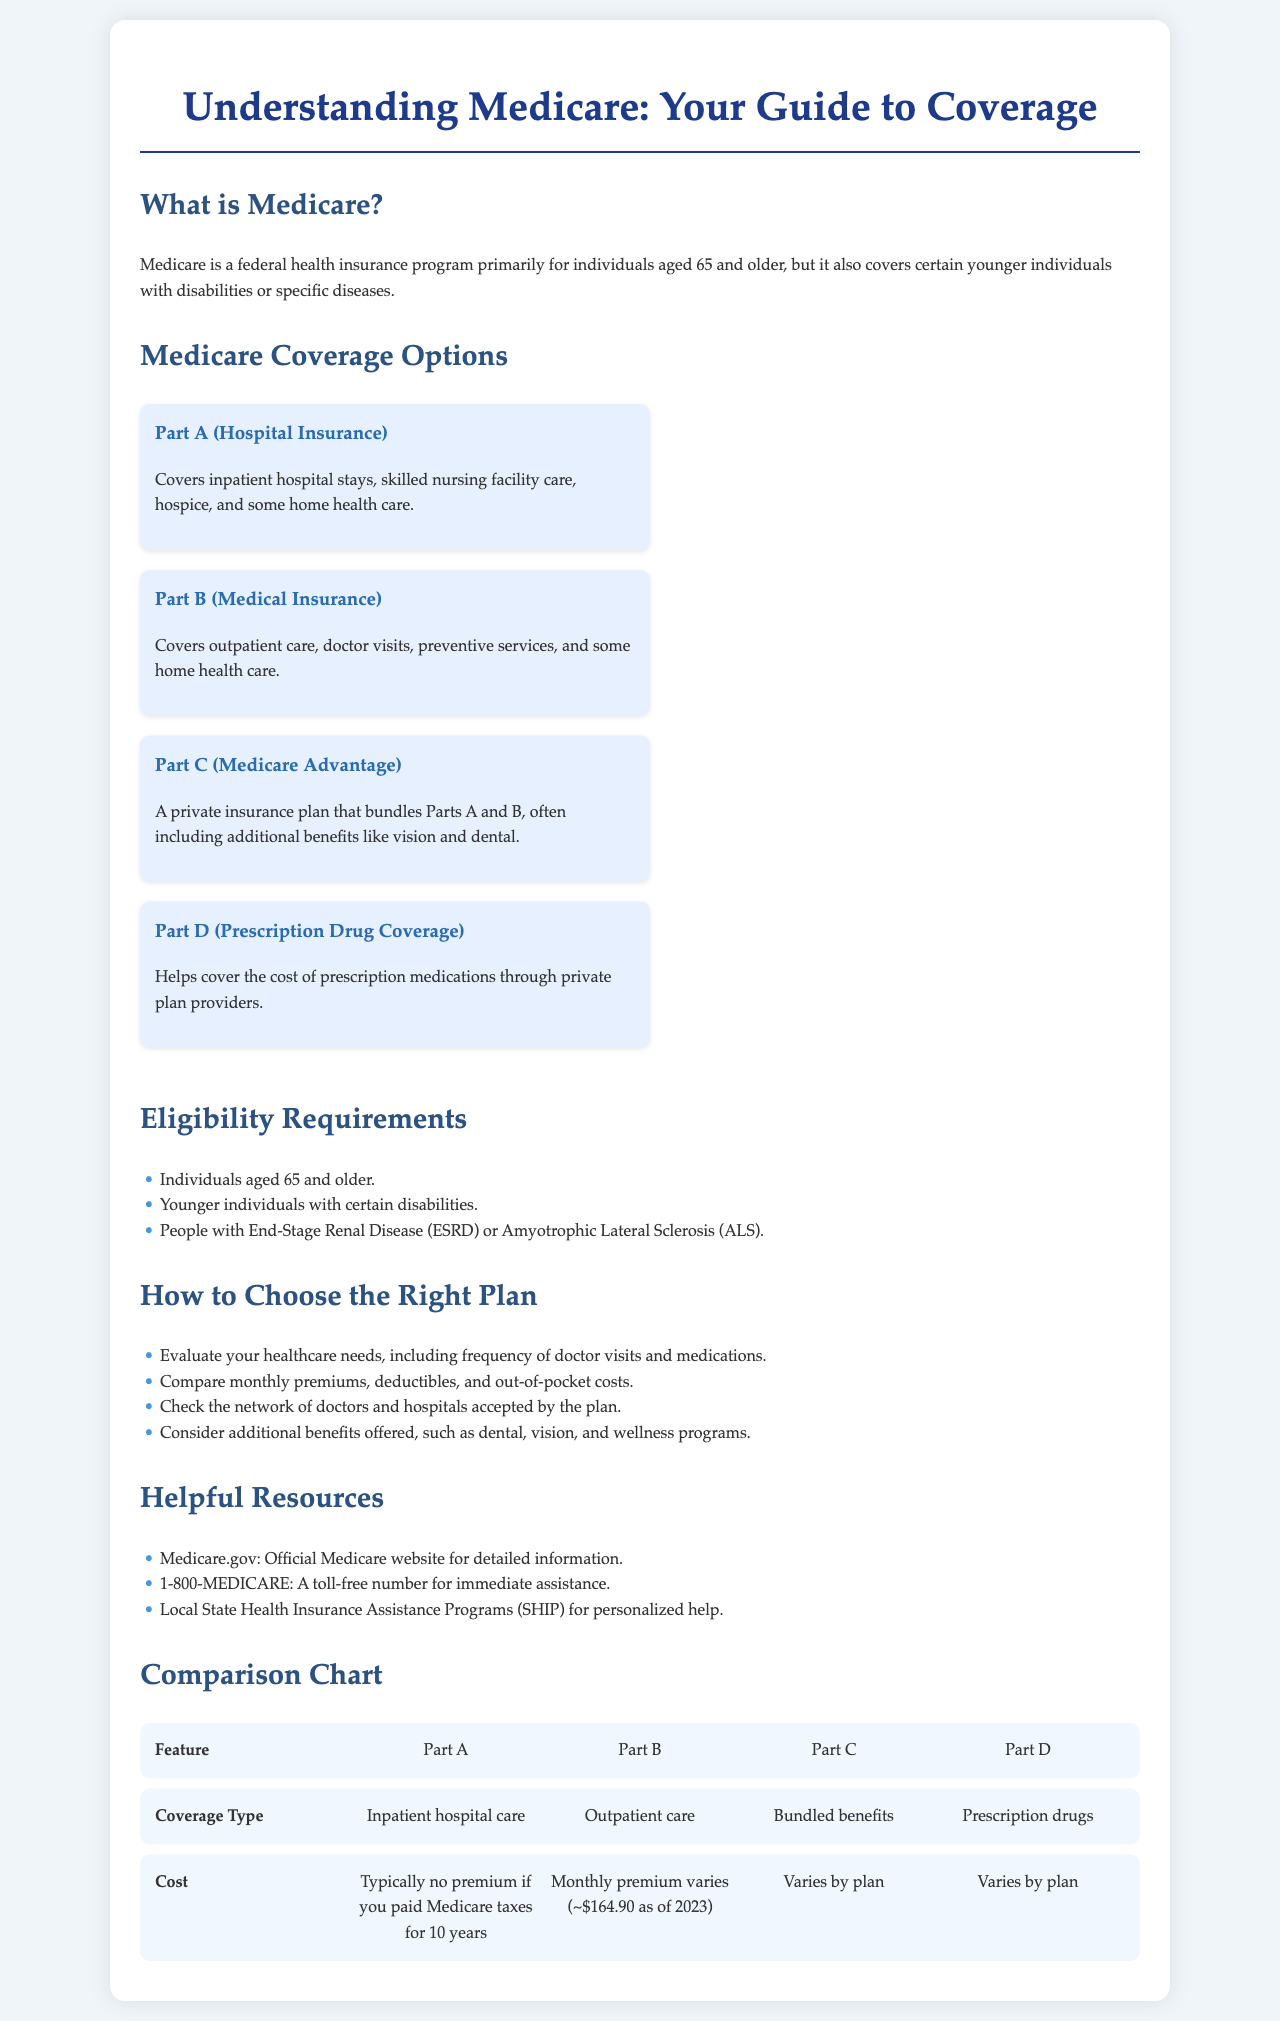What is Medicare? Medicare is a federal health insurance program primarily for individuals aged 65 and older, but it also covers certain younger individuals with disabilities or specific diseases.
Answer: Federal health insurance program What age must you be to qualify for Medicare? Individuals aged 65 and older are eligible for Medicare as stated in the document.
Answer: 65 What type of care does Part A cover? The document specifies that Part A covers inpatient hospital stays, skilled nursing facility care, hospice, and some home health care.
Answer: Inpatient hospital stays How often does Part B's monthly premium vary? The document indicates that the monthly premium for Part B varies, with an example given as approximately $164.90 as of 2023.
Answer: ~$164.90 What should you evaluate when choosing a Medicare plan? According to the brochure, you should evaluate your healthcare needs, including frequency of doctor visits and medications.
Answer: Healthcare needs Which resource can you call for immediate assistance regarding Medicare? The document lists 1-800-MEDICARE as a toll-free number for immediate assistance.
Answer: 1-800-MEDICARE What additional benefits might Part C include? The brochure mentions that Part C, or Medicare Advantage, often includes additional benefits like vision and dental.
Answer: Vision and dental How is the cost of Part D determined? The cost of Part D varies by plan, as stated in the comparison chart.
Answer: Varies by plan 